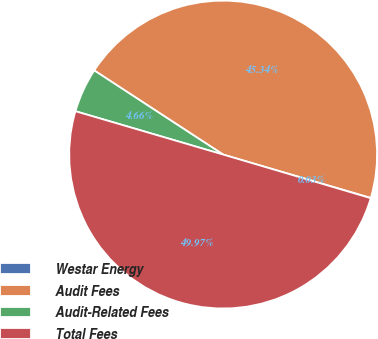<chart> <loc_0><loc_0><loc_500><loc_500><pie_chart><fcel>Westar Energy<fcel>Audit Fees<fcel>Audit-Related Fees<fcel>Total Fees<nl><fcel>0.03%<fcel>45.34%<fcel>4.66%<fcel>49.97%<nl></chart> 